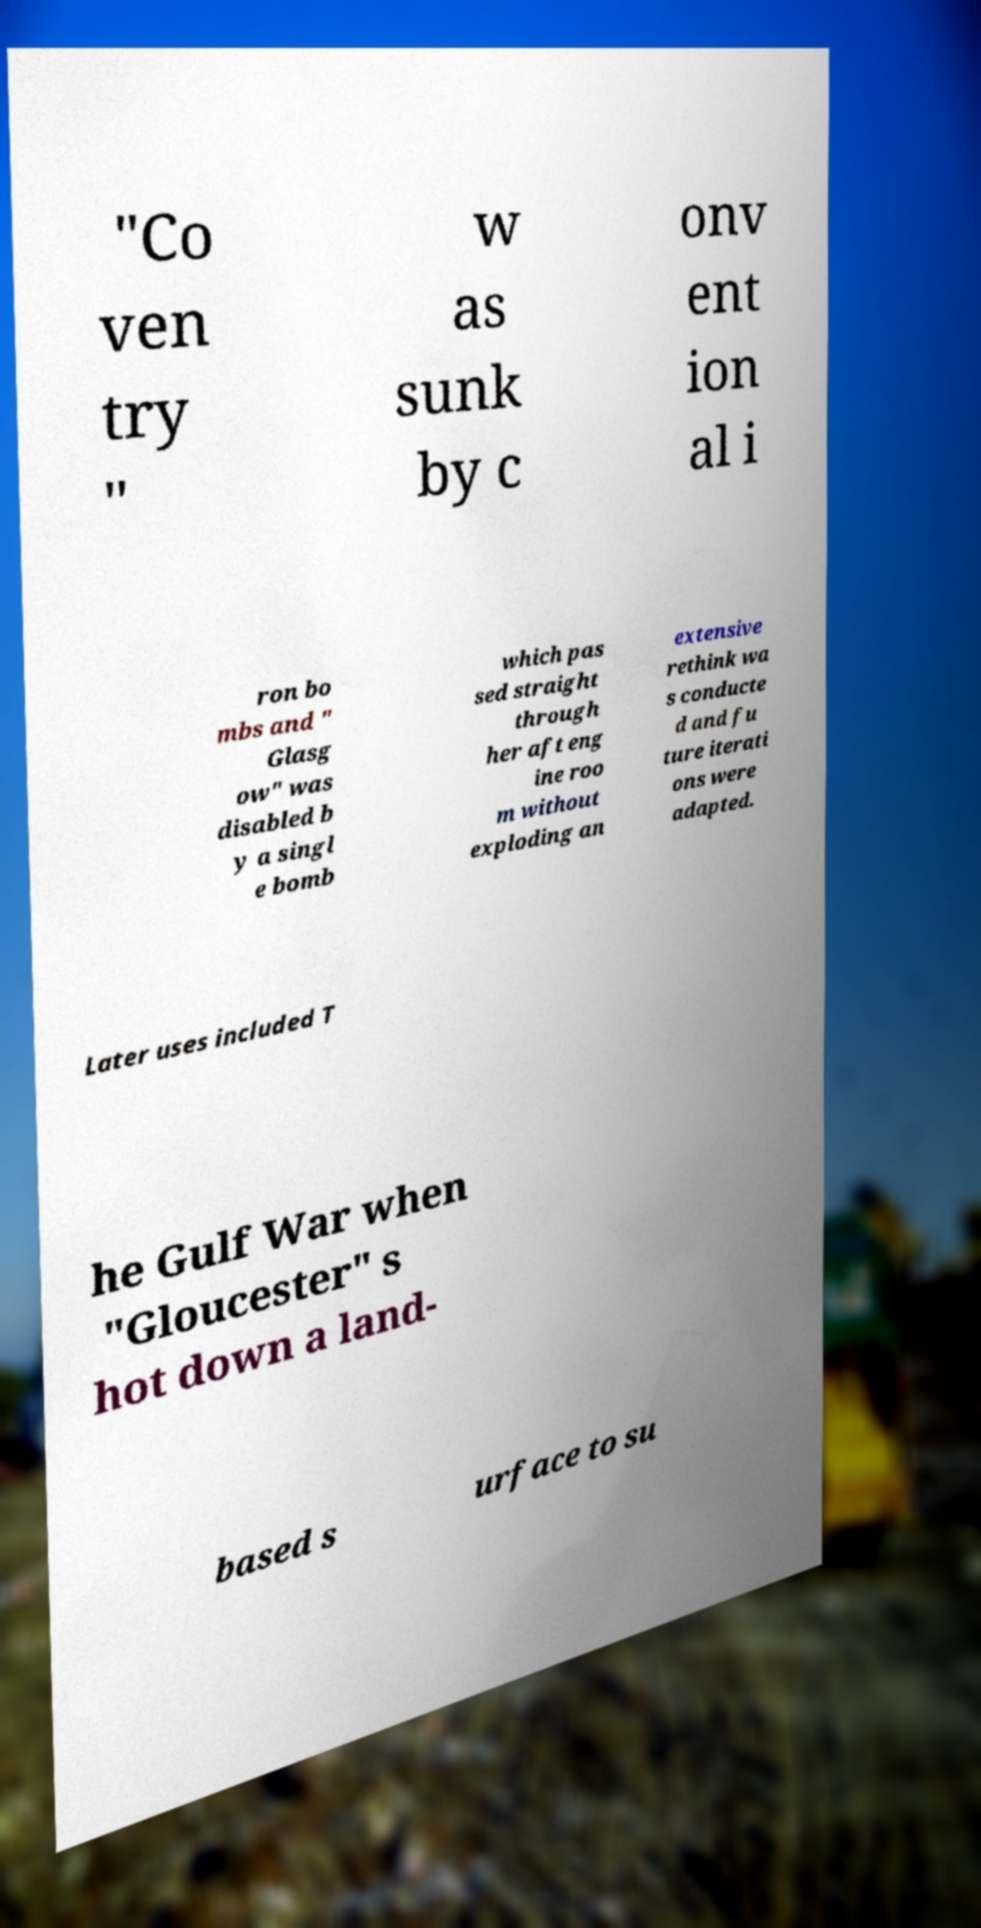Could you assist in decoding the text presented in this image and type it out clearly? "Co ven try " w as sunk by c onv ent ion al i ron bo mbs and " Glasg ow" was disabled b y a singl e bomb which pas sed straight through her aft eng ine roo m without exploding an extensive rethink wa s conducte d and fu ture iterati ons were adapted. Later uses included T he Gulf War when "Gloucester" s hot down a land- based s urface to su 